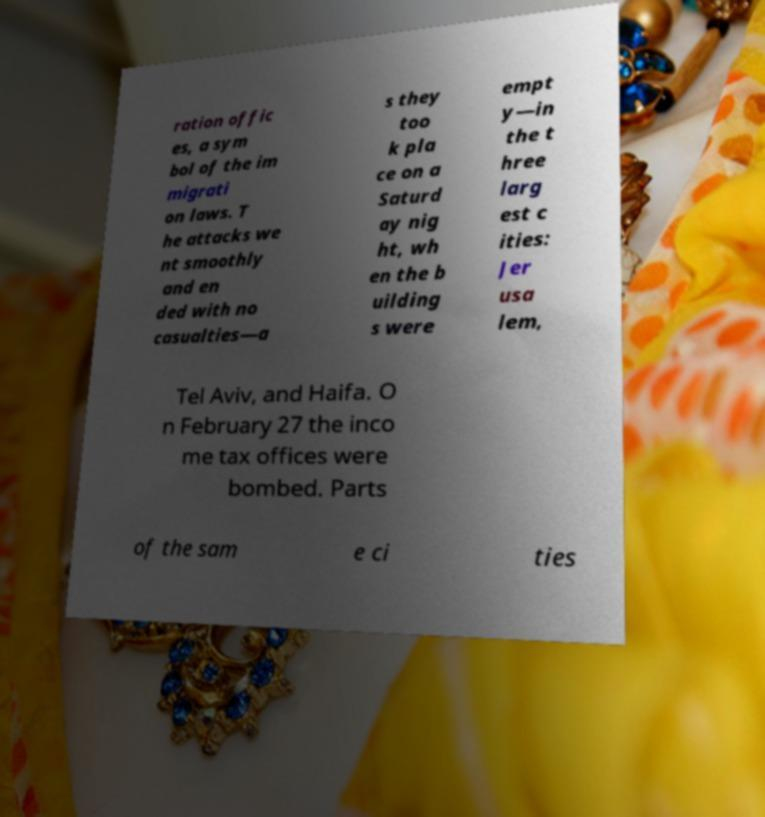Could you assist in decoding the text presented in this image and type it out clearly? ration offic es, a sym bol of the im migrati on laws. T he attacks we nt smoothly and en ded with no casualties—a s they too k pla ce on a Saturd ay nig ht, wh en the b uilding s were empt y—in the t hree larg est c ities: Jer usa lem, Tel Aviv, and Haifa. O n February 27 the inco me tax offices were bombed. Parts of the sam e ci ties 